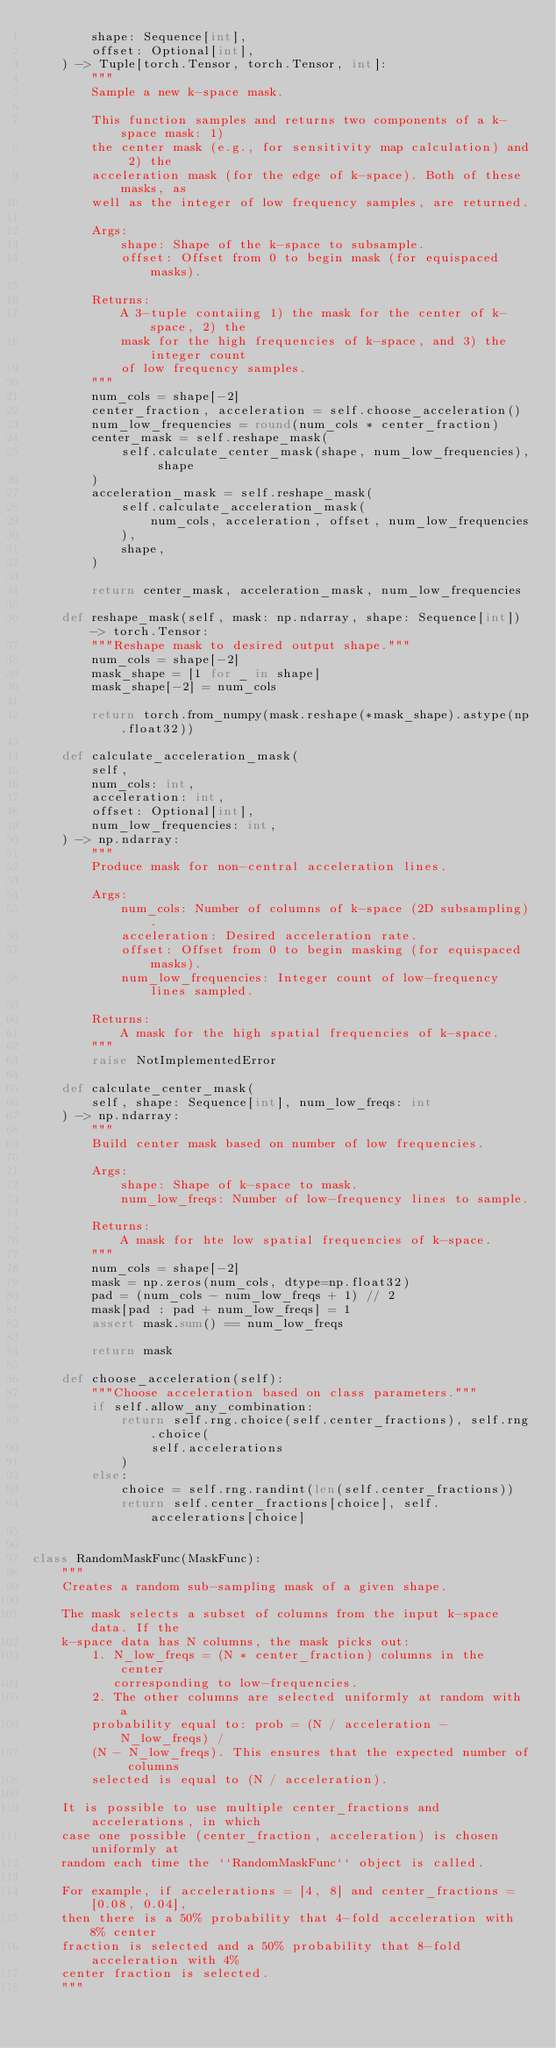Convert code to text. <code><loc_0><loc_0><loc_500><loc_500><_Python_>        shape: Sequence[int],
        offset: Optional[int],
    ) -> Tuple[torch.Tensor, torch.Tensor, int]:
        """
        Sample a new k-space mask.

        This function samples and returns two components of a k-space mask: 1)
        the center mask (e.g., for sensitivity map calculation) and 2) the
        acceleration mask (for the edge of k-space). Both of these masks, as
        well as the integer of low frequency samples, are returned.

        Args:
            shape: Shape of the k-space to subsample.
            offset: Offset from 0 to begin mask (for equispaced masks).

        Returns:
            A 3-tuple contaiing 1) the mask for the center of k-space, 2) the
            mask for the high frequencies of k-space, and 3) the integer count
            of low frequency samples.
        """
        num_cols = shape[-2]
        center_fraction, acceleration = self.choose_acceleration()
        num_low_frequencies = round(num_cols * center_fraction)
        center_mask = self.reshape_mask(
            self.calculate_center_mask(shape, num_low_frequencies), shape
        )
        acceleration_mask = self.reshape_mask(
            self.calculate_acceleration_mask(
                num_cols, acceleration, offset, num_low_frequencies
            ),
            shape,
        )

        return center_mask, acceleration_mask, num_low_frequencies

    def reshape_mask(self, mask: np.ndarray, shape: Sequence[int]) -> torch.Tensor:
        """Reshape mask to desired output shape."""
        num_cols = shape[-2]
        mask_shape = [1 for _ in shape]
        mask_shape[-2] = num_cols

        return torch.from_numpy(mask.reshape(*mask_shape).astype(np.float32))

    def calculate_acceleration_mask(
        self,
        num_cols: int,
        acceleration: int,
        offset: Optional[int],
        num_low_frequencies: int,
    ) -> np.ndarray:
        """
        Produce mask for non-central acceleration lines.

        Args:
            num_cols: Number of columns of k-space (2D subsampling).
            acceleration: Desired acceleration rate.
            offset: Offset from 0 to begin masking (for equispaced masks).
            num_low_frequencies: Integer count of low-frequency lines sampled.

        Returns:
            A mask for the high spatial frequencies of k-space.
        """
        raise NotImplementedError

    def calculate_center_mask(
        self, shape: Sequence[int], num_low_freqs: int
    ) -> np.ndarray:
        """
        Build center mask based on number of low frequencies.

        Args:
            shape: Shape of k-space to mask.
            num_low_freqs: Number of low-frequency lines to sample.

        Returns:
            A mask for hte low spatial frequencies of k-space.
        """
        num_cols = shape[-2]
        mask = np.zeros(num_cols, dtype=np.float32)
        pad = (num_cols - num_low_freqs + 1) // 2
        mask[pad : pad + num_low_freqs] = 1
        assert mask.sum() == num_low_freqs

        return mask

    def choose_acceleration(self):
        """Choose acceleration based on class parameters."""
        if self.allow_any_combination:
            return self.rng.choice(self.center_fractions), self.rng.choice(
                self.accelerations
            )
        else:
            choice = self.rng.randint(len(self.center_fractions))
            return self.center_fractions[choice], self.accelerations[choice]


class RandomMaskFunc(MaskFunc):
    """
    Creates a random sub-sampling mask of a given shape.

    The mask selects a subset of columns from the input k-space data. If the
    k-space data has N columns, the mask picks out:
        1. N_low_freqs = (N * center_fraction) columns in the center
           corresponding to low-frequencies.
        2. The other columns are selected uniformly at random with a
        probability equal to: prob = (N / acceleration - N_low_freqs) /
        (N - N_low_freqs). This ensures that the expected number of columns
        selected is equal to (N / acceleration).

    It is possible to use multiple center_fractions and accelerations, in which
    case one possible (center_fraction, acceleration) is chosen uniformly at
    random each time the ``RandomMaskFunc`` object is called.

    For example, if accelerations = [4, 8] and center_fractions = [0.08, 0.04],
    then there is a 50% probability that 4-fold acceleration with 8% center
    fraction is selected and a 50% probability that 8-fold acceleration with 4%
    center fraction is selected.
    """
</code> 